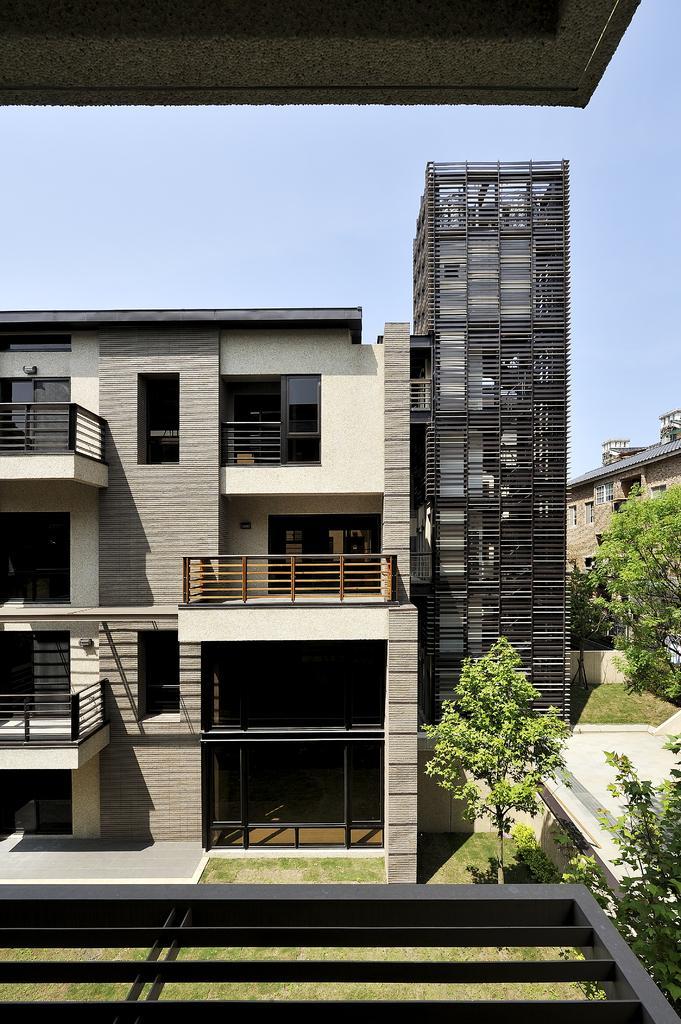How would you summarize this image in a sentence or two? In this image there is a building in the middle. Beside the building there is another tall building. At the bottom there are trees on the ground. At the top there is sky. 